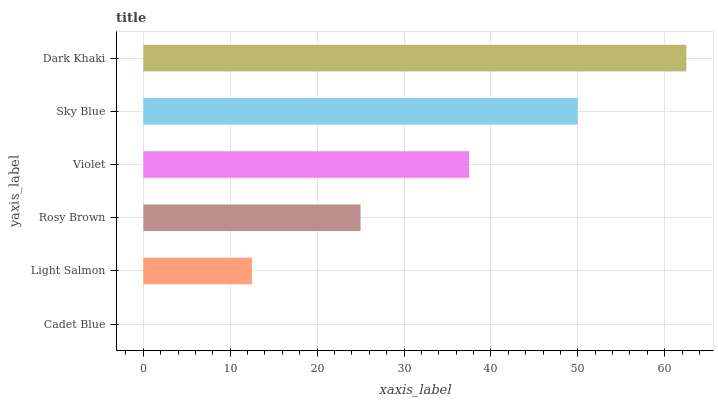Is Cadet Blue the minimum?
Answer yes or no. Yes. Is Dark Khaki the maximum?
Answer yes or no. Yes. Is Light Salmon the minimum?
Answer yes or no. No. Is Light Salmon the maximum?
Answer yes or no. No. Is Light Salmon greater than Cadet Blue?
Answer yes or no. Yes. Is Cadet Blue less than Light Salmon?
Answer yes or no. Yes. Is Cadet Blue greater than Light Salmon?
Answer yes or no. No. Is Light Salmon less than Cadet Blue?
Answer yes or no. No. Is Violet the high median?
Answer yes or no. Yes. Is Rosy Brown the low median?
Answer yes or no. Yes. Is Sky Blue the high median?
Answer yes or no. No. Is Violet the low median?
Answer yes or no. No. 